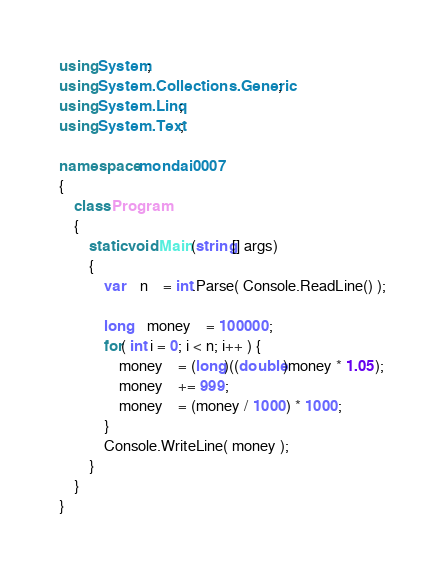Convert code to text. <code><loc_0><loc_0><loc_500><loc_500><_C#_>using System;
using System.Collections.Generic;
using System.Linq;
using System.Text;

namespace mondai0007
{
	class Program
	{
		static void Main(string[] args)
		{
			var	n	= int.Parse( Console.ReadLine() );

			long	money	= 100000;
			for( int i = 0; i < n; i++ ) {
				money	= (long)((double)money * 1.05);
				money	+= 999;
				money	= (money / 1000) * 1000;
			}
			Console.WriteLine( money );
		}
	}
}</code> 